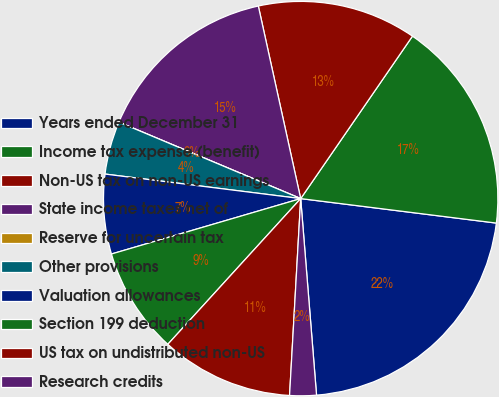<chart> <loc_0><loc_0><loc_500><loc_500><pie_chart><fcel>Years ended December 31<fcel>Income tax expense (benefit)<fcel>Non-US tax on non-US earnings<fcel>State income taxes net of<fcel>Reserve for uncertain tax<fcel>Other provisions<fcel>Valuation allowances<fcel>Section 199 deduction<fcel>US tax on undistributed non-US<fcel>Research credits<nl><fcel>21.74%<fcel>17.39%<fcel>13.04%<fcel>15.22%<fcel>0.0%<fcel>4.35%<fcel>6.52%<fcel>8.7%<fcel>10.87%<fcel>2.18%<nl></chart> 